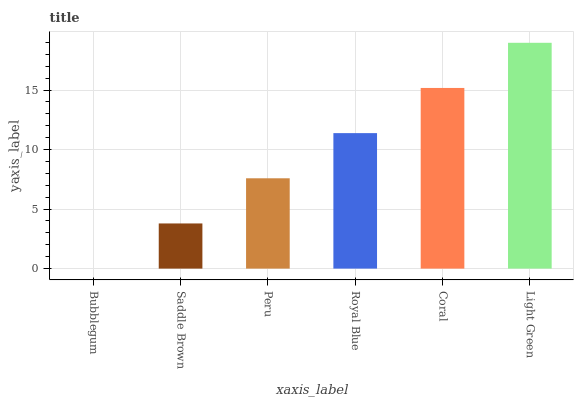Is Bubblegum the minimum?
Answer yes or no. Yes. Is Light Green the maximum?
Answer yes or no. Yes. Is Saddle Brown the minimum?
Answer yes or no. No. Is Saddle Brown the maximum?
Answer yes or no. No. Is Saddle Brown greater than Bubblegum?
Answer yes or no. Yes. Is Bubblegum less than Saddle Brown?
Answer yes or no. Yes. Is Bubblegum greater than Saddle Brown?
Answer yes or no. No. Is Saddle Brown less than Bubblegum?
Answer yes or no. No. Is Royal Blue the high median?
Answer yes or no. Yes. Is Peru the low median?
Answer yes or no. Yes. Is Coral the high median?
Answer yes or no. No. Is Coral the low median?
Answer yes or no. No. 